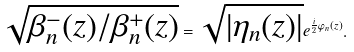Convert formula to latex. <formula><loc_0><loc_0><loc_500><loc_500>\sqrt { \beta ^ { - } _ { n } ( z ) / \beta ^ { + } _ { n } ( z ) } = \sqrt { | \eta _ { n } ( z ) | } e ^ { \frac { i } { 2 } \varphi _ { n } ( z ) } .</formula> 